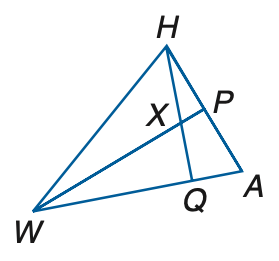Answer the mathemtical geometry problem and directly provide the correct option letter.
Question: If W P is a median and an angle bisector, A P = 3 y + 11, P H = 7 y - 5, m \angle H W P = x + 12, m \angle P A W = 3 x - 2, and m \angle H W A = 4 x - 16, find y.
Choices: A: 3 B: 4 C: 5 D: 6 B 